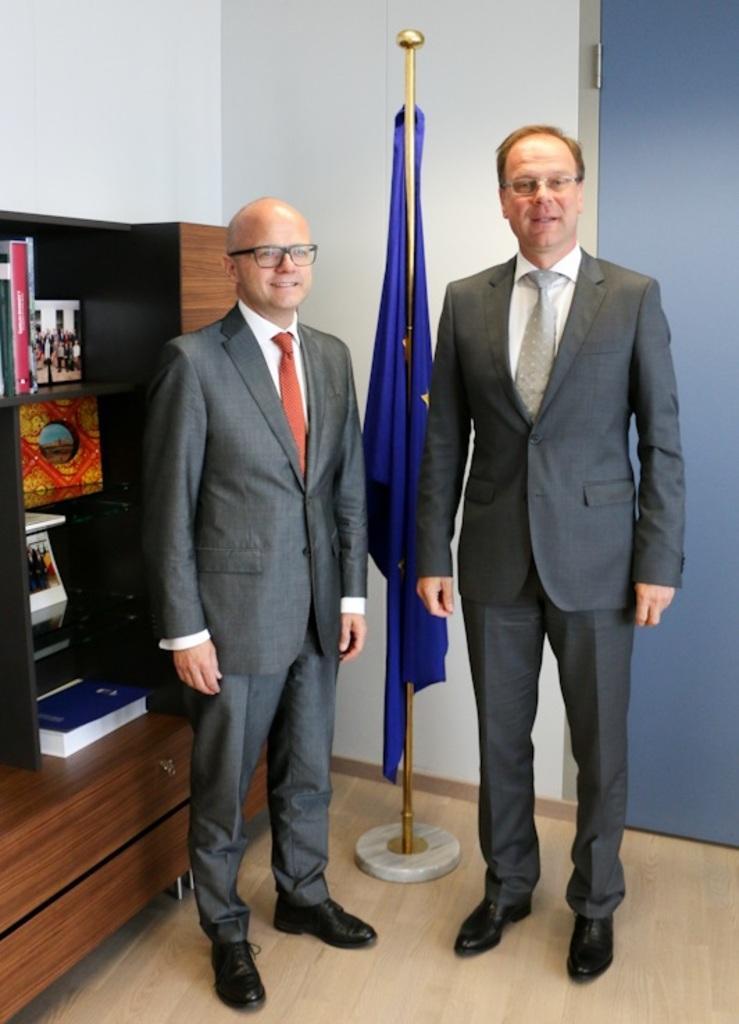Can you describe this image briefly? In this image we can see two men standing in the room there is a flag with rod behind them, beside a man on the left side there is a shelf with books and picture frames and there is a door behind the man on the right side. 